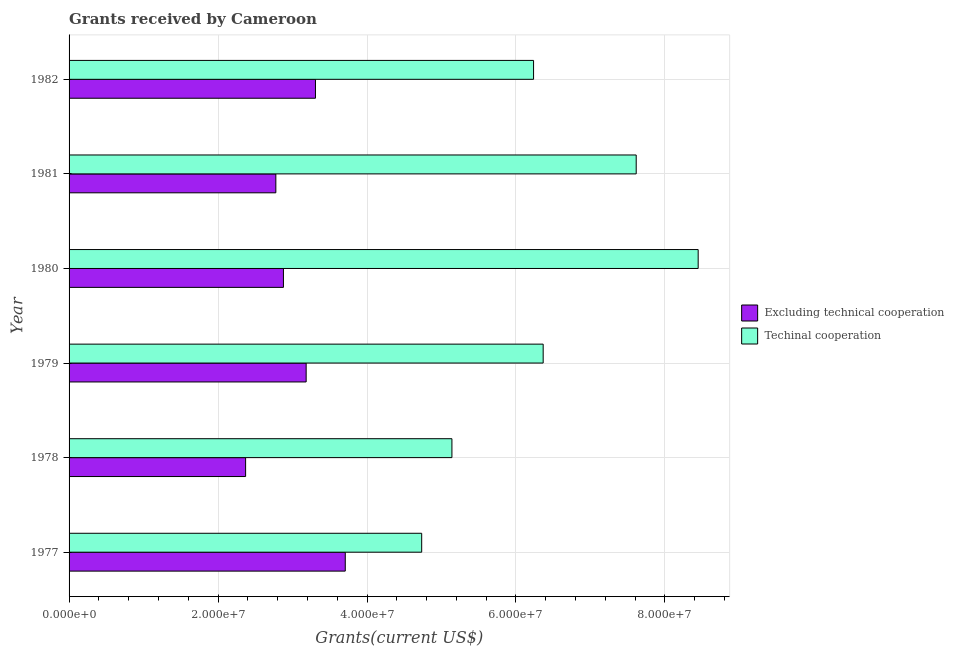How many different coloured bars are there?
Offer a terse response. 2. How many groups of bars are there?
Provide a short and direct response. 6. How many bars are there on the 2nd tick from the top?
Provide a short and direct response. 2. How many bars are there on the 3rd tick from the bottom?
Provide a succinct answer. 2. In how many cases, is the number of bars for a given year not equal to the number of legend labels?
Give a very brief answer. 0. What is the amount of grants received(including technical cooperation) in 1977?
Make the answer very short. 4.73e+07. Across all years, what is the maximum amount of grants received(excluding technical cooperation)?
Your response must be concise. 3.71e+07. Across all years, what is the minimum amount of grants received(including technical cooperation)?
Make the answer very short. 4.73e+07. In which year was the amount of grants received(including technical cooperation) maximum?
Keep it short and to the point. 1980. In which year was the amount of grants received(excluding technical cooperation) minimum?
Offer a very short reply. 1978. What is the total amount of grants received(excluding technical cooperation) in the graph?
Offer a very short reply. 1.82e+08. What is the difference between the amount of grants received(including technical cooperation) in 1978 and that in 1980?
Give a very brief answer. -3.31e+07. What is the difference between the amount of grants received(excluding technical cooperation) in 1981 and the amount of grants received(including technical cooperation) in 1982?
Offer a very short reply. -3.46e+07. What is the average amount of grants received(including technical cooperation) per year?
Give a very brief answer. 6.42e+07. In the year 1979, what is the difference between the amount of grants received(excluding technical cooperation) and amount of grants received(including technical cooperation)?
Give a very brief answer. -3.18e+07. In how many years, is the amount of grants received(including technical cooperation) greater than 44000000 US$?
Ensure brevity in your answer.  6. What is the ratio of the amount of grants received(excluding technical cooperation) in 1978 to that in 1980?
Provide a short and direct response. 0.82. Is the amount of grants received(excluding technical cooperation) in 1979 less than that in 1981?
Offer a terse response. No. Is the difference between the amount of grants received(excluding technical cooperation) in 1978 and 1982 greater than the difference between the amount of grants received(including technical cooperation) in 1978 and 1982?
Keep it short and to the point. Yes. What is the difference between the highest and the second highest amount of grants received(including technical cooperation)?
Your response must be concise. 8.32e+06. What is the difference between the highest and the lowest amount of grants received(excluding technical cooperation)?
Make the answer very short. 1.34e+07. What does the 1st bar from the top in 1977 represents?
Offer a very short reply. Techinal cooperation. What does the 1st bar from the bottom in 1982 represents?
Your response must be concise. Excluding technical cooperation. How many years are there in the graph?
Provide a short and direct response. 6. Are the values on the major ticks of X-axis written in scientific E-notation?
Your answer should be very brief. Yes. Does the graph contain any zero values?
Your answer should be compact. No. Does the graph contain grids?
Ensure brevity in your answer.  Yes. Where does the legend appear in the graph?
Provide a short and direct response. Center right. How are the legend labels stacked?
Give a very brief answer. Vertical. What is the title of the graph?
Make the answer very short. Grants received by Cameroon. What is the label or title of the X-axis?
Your answer should be compact. Grants(current US$). What is the Grants(current US$) in Excluding technical cooperation in 1977?
Your response must be concise. 3.71e+07. What is the Grants(current US$) of Techinal cooperation in 1977?
Your answer should be very brief. 4.73e+07. What is the Grants(current US$) of Excluding technical cooperation in 1978?
Your response must be concise. 2.37e+07. What is the Grants(current US$) in Techinal cooperation in 1978?
Give a very brief answer. 5.14e+07. What is the Grants(current US$) in Excluding technical cooperation in 1979?
Make the answer very short. 3.18e+07. What is the Grants(current US$) in Techinal cooperation in 1979?
Offer a very short reply. 6.36e+07. What is the Grants(current US$) in Excluding technical cooperation in 1980?
Your answer should be very brief. 2.88e+07. What is the Grants(current US$) of Techinal cooperation in 1980?
Make the answer very short. 8.45e+07. What is the Grants(current US$) of Excluding technical cooperation in 1981?
Your answer should be very brief. 2.78e+07. What is the Grants(current US$) in Techinal cooperation in 1981?
Give a very brief answer. 7.61e+07. What is the Grants(current US$) of Excluding technical cooperation in 1982?
Provide a succinct answer. 3.31e+07. What is the Grants(current US$) in Techinal cooperation in 1982?
Make the answer very short. 6.24e+07. Across all years, what is the maximum Grants(current US$) in Excluding technical cooperation?
Ensure brevity in your answer.  3.71e+07. Across all years, what is the maximum Grants(current US$) of Techinal cooperation?
Offer a very short reply. 8.45e+07. Across all years, what is the minimum Grants(current US$) of Excluding technical cooperation?
Provide a succinct answer. 2.37e+07. Across all years, what is the minimum Grants(current US$) in Techinal cooperation?
Your answer should be very brief. 4.73e+07. What is the total Grants(current US$) of Excluding technical cooperation in the graph?
Your answer should be very brief. 1.82e+08. What is the total Grants(current US$) of Techinal cooperation in the graph?
Your answer should be compact. 3.85e+08. What is the difference between the Grants(current US$) of Excluding technical cooperation in 1977 and that in 1978?
Offer a very short reply. 1.34e+07. What is the difference between the Grants(current US$) in Techinal cooperation in 1977 and that in 1978?
Your answer should be very brief. -4.06e+06. What is the difference between the Grants(current US$) in Excluding technical cooperation in 1977 and that in 1979?
Offer a terse response. 5.25e+06. What is the difference between the Grants(current US$) in Techinal cooperation in 1977 and that in 1979?
Keep it short and to the point. -1.63e+07. What is the difference between the Grants(current US$) in Excluding technical cooperation in 1977 and that in 1980?
Offer a terse response. 8.30e+06. What is the difference between the Grants(current US$) in Techinal cooperation in 1977 and that in 1980?
Your response must be concise. -3.71e+07. What is the difference between the Grants(current US$) of Excluding technical cooperation in 1977 and that in 1981?
Provide a short and direct response. 9.32e+06. What is the difference between the Grants(current US$) of Techinal cooperation in 1977 and that in 1981?
Your response must be concise. -2.88e+07. What is the difference between the Grants(current US$) in Techinal cooperation in 1977 and that in 1982?
Your answer should be compact. -1.50e+07. What is the difference between the Grants(current US$) of Excluding technical cooperation in 1978 and that in 1979?
Ensure brevity in your answer.  -8.13e+06. What is the difference between the Grants(current US$) of Techinal cooperation in 1978 and that in 1979?
Make the answer very short. -1.22e+07. What is the difference between the Grants(current US$) of Excluding technical cooperation in 1978 and that in 1980?
Ensure brevity in your answer.  -5.08e+06. What is the difference between the Grants(current US$) of Techinal cooperation in 1978 and that in 1980?
Keep it short and to the point. -3.31e+07. What is the difference between the Grants(current US$) in Excluding technical cooperation in 1978 and that in 1981?
Your response must be concise. -4.06e+06. What is the difference between the Grants(current US$) of Techinal cooperation in 1978 and that in 1981?
Provide a succinct answer. -2.47e+07. What is the difference between the Grants(current US$) of Excluding technical cooperation in 1978 and that in 1982?
Offer a terse response. -9.38e+06. What is the difference between the Grants(current US$) of Techinal cooperation in 1978 and that in 1982?
Your answer should be compact. -1.10e+07. What is the difference between the Grants(current US$) in Excluding technical cooperation in 1979 and that in 1980?
Your response must be concise. 3.05e+06. What is the difference between the Grants(current US$) in Techinal cooperation in 1979 and that in 1980?
Provide a short and direct response. -2.08e+07. What is the difference between the Grants(current US$) of Excluding technical cooperation in 1979 and that in 1981?
Offer a very short reply. 4.07e+06. What is the difference between the Grants(current US$) in Techinal cooperation in 1979 and that in 1981?
Your answer should be very brief. -1.25e+07. What is the difference between the Grants(current US$) in Excluding technical cooperation in 1979 and that in 1982?
Make the answer very short. -1.25e+06. What is the difference between the Grants(current US$) of Techinal cooperation in 1979 and that in 1982?
Make the answer very short. 1.29e+06. What is the difference between the Grants(current US$) of Excluding technical cooperation in 1980 and that in 1981?
Your answer should be very brief. 1.02e+06. What is the difference between the Grants(current US$) of Techinal cooperation in 1980 and that in 1981?
Provide a short and direct response. 8.32e+06. What is the difference between the Grants(current US$) of Excluding technical cooperation in 1980 and that in 1982?
Offer a very short reply. -4.30e+06. What is the difference between the Grants(current US$) of Techinal cooperation in 1980 and that in 1982?
Ensure brevity in your answer.  2.21e+07. What is the difference between the Grants(current US$) in Excluding technical cooperation in 1981 and that in 1982?
Keep it short and to the point. -5.32e+06. What is the difference between the Grants(current US$) in Techinal cooperation in 1981 and that in 1982?
Make the answer very short. 1.38e+07. What is the difference between the Grants(current US$) of Excluding technical cooperation in 1977 and the Grants(current US$) of Techinal cooperation in 1978?
Make the answer very short. -1.43e+07. What is the difference between the Grants(current US$) of Excluding technical cooperation in 1977 and the Grants(current US$) of Techinal cooperation in 1979?
Give a very brief answer. -2.66e+07. What is the difference between the Grants(current US$) of Excluding technical cooperation in 1977 and the Grants(current US$) of Techinal cooperation in 1980?
Make the answer very short. -4.74e+07. What is the difference between the Grants(current US$) of Excluding technical cooperation in 1977 and the Grants(current US$) of Techinal cooperation in 1981?
Ensure brevity in your answer.  -3.91e+07. What is the difference between the Grants(current US$) in Excluding technical cooperation in 1977 and the Grants(current US$) in Techinal cooperation in 1982?
Make the answer very short. -2.53e+07. What is the difference between the Grants(current US$) in Excluding technical cooperation in 1978 and the Grants(current US$) in Techinal cooperation in 1979?
Keep it short and to the point. -4.00e+07. What is the difference between the Grants(current US$) of Excluding technical cooperation in 1978 and the Grants(current US$) of Techinal cooperation in 1980?
Offer a terse response. -6.08e+07. What is the difference between the Grants(current US$) in Excluding technical cooperation in 1978 and the Grants(current US$) in Techinal cooperation in 1981?
Offer a very short reply. -5.24e+07. What is the difference between the Grants(current US$) in Excluding technical cooperation in 1978 and the Grants(current US$) in Techinal cooperation in 1982?
Give a very brief answer. -3.87e+07. What is the difference between the Grants(current US$) in Excluding technical cooperation in 1979 and the Grants(current US$) in Techinal cooperation in 1980?
Offer a very short reply. -5.26e+07. What is the difference between the Grants(current US$) in Excluding technical cooperation in 1979 and the Grants(current US$) in Techinal cooperation in 1981?
Your response must be concise. -4.43e+07. What is the difference between the Grants(current US$) in Excluding technical cooperation in 1979 and the Grants(current US$) in Techinal cooperation in 1982?
Provide a succinct answer. -3.05e+07. What is the difference between the Grants(current US$) of Excluding technical cooperation in 1980 and the Grants(current US$) of Techinal cooperation in 1981?
Provide a succinct answer. -4.74e+07. What is the difference between the Grants(current US$) of Excluding technical cooperation in 1980 and the Grants(current US$) of Techinal cooperation in 1982?
Your answer should be very brief. -3.36e+07. What is the difference between the Grants(current US$) in Excluding technical cooperation in 1981 and the Grants(current US$) in Techinal cooperation in 1982?
Make the answer very short. -3.46e+07. What is the average Grants(current US$) of Excluding technical cooperation per year?
Provide a succinct answer. 3.04e+07. What is the average Grants(current US$) in Techinal cooperation per year?
Ensure brevity in your answer.  6.42e+07. In the year 1977, what is the difference between the Grants(current US$) of Excluding technical cooperation and Grants(current US$) of Techinal cooperation?
Offer a very short reply. -1.03e+07. In the year 1978, what is the difference between the Grants(current US$) of Excluding technical cooperation and Grants(current US$) of Techinal cooperation?
Keep it short and to the point. -2.77e+07. In the year 1979, what is the difference between the Grants(current US$) of Excluding technical cooperation and Grants(current US$) of Techinal cooperation?
Offer a terse response. -3.18e+07. In the year 1980, what is the difference between the Grants(current US$) of Excluding technical cooperation and Grants(current US$) of Techinal cooperation?
Provide a short and direct response. -5.57e+07. In the year 1981, what is the difference between the Grants(current US$) of Excluding technical cooperation and Grants(current US$) of Techinal cooperation?
Your answer should be very brief. -4.84e+07. In the year 1982, what is the difference between the Grants(current US$) in Excluding technical cooperation and Grants(current US$) in Techinal cooperation?
Offer a very short reply. -2.93e+07. What is the ratio of the Grants(current US$) in Excluding technical cooperation in 1977 to that in 1978?
Provide a succinct answer. 1.56. What is the ratio of the Grants(current US$) in Techinal cooperation in 1977 to that in 1978?
Offer a very short reply. 0.92. What is the ratio of the Grants(current US$) in Excluding technical cooperation in 1977 to that in 1979?
Offer a very short reply. 1.16. What is the ratio of the Grants(current US$) of Techinal cooperation in 1977 to that in 1979?
Your response must be concise. 0.74. What is the ratio of the Grants(current US$) of Excluding technical cooperation in 1977 to that in 1980?
Your answer should be very brief. 1.29. What is the ratio of the Grants(current US$) of Techinal cooperation in 1977 to that in 1980?
Your answer should be very brief. 0.56. What is the ratio of the Grants(current US$) of Excluding technical cooperation in 1977 to that in 1981?
Provide a succinct answer. 1.34. What is the ratio of the Grants(current US$) of Techinal cooperation in 1977 to that in 1981?
Your answer should be compact. 0.62. What is the ratio of the Grants(current US$) in Excluding technical cooperation in 1977 to that in 1982?
Your answer should be very brief. 1.12. What is the ratio of the Grants(current US$) in Techinal cooperation in 1977 to that in 1982?
Your response must be concise. 0.76. What is the ratio of the Grants(current US$) of Excluding technical cooperation in 1978 to that in 1979?
Offer a terse response. 0.74. What is the ratio of the Grants(current US$) in Techinal cooperation in 1978 to that in 1979?
Keep it short and to the point. 0.81. What is the ratio of the Grants(current US$) in Excluding technical cooperation in 1978 to that in 1980?
Offer a terse response. 0.82. What is the ratio of the Grants(current US$) in Techinal cooperation in 1978 to that in 1980?
Your answer should be compact. 0.61. What is the ratio of the Grants(current US$) in Excluding technical cooperation in 1978 to that in 1981?
Offer a very short reply. 0.85. What is the ratio of the Grants(current US$) of Techinal cooperation in 1978 to that in 1981?
Offer a terse response. 0.68. What is the ratio of the Grants(current US$) in Excluding technical cooperation in 1978 to that in 1982?
Provide a succinct answer. 0.72. What is the ratio of the Grants(current US$) of Techinal cooperation in 1978 to that in 1982?
Offer a terse response. 0.82. What is the ratio of the Grants(current US$) in Excluding technical cooperation in 1979 to that in 1980?
Offer a very short reply. 1.11. What is the ratio of the Grants(current US$) of Techinal cooperation in 1979 to that in 1980?
Ensure brevity in your answer.  0.75. What is the ratio of the Grants(current US$) of Excluding technical cooperation in 1979 to that in 1981?
Provide a succinct answer. 1.15. What is the ratio of the Grants(current US$) in Techinal cooperation in 1979 to that in 1981?
Give a very brief answer. 0.84. What is the ratio of the Grants(current US$) of Excluding technical cooperation in 1979 to that in 1982?
Ensure brevity in your answer.  0.96. What is the ratio of the Grants(current US$) in Techinal cooperation in 1979 to that in 1982?
Offer a very short reply. 1.02. What is the ratio of the Grants(current US$) in Excluding technical cooperation in 1980 to that in 1981?
Provide a short and direct response. 1.04. What is the ratio of the Grants(current US$) of Techinal cooperation in 1980 to that in 1981?
Keep it short and to the point. 1.11. What is the ratio of the Grants(current US$) of Excluding technical cooperation in 1980 to that in 1982?
Your response must be concise. 0.87. What is the ratio of the Grants(current US$) of Techinal cooperation in 1980 to that in 1982?
Keep it short and to the point. 1.35. What is the ratio of the Grants(current US$) in Excluding technical cooperation in 1981 to that in 1982?
Ensure brevity in your answer.  0.84. What is the ratio of the Grants(current US$) in Techinal cooperation in 1981 to that in 1982?
Make the answer very short. 1.22. What is the difference between the highest and the second highest Grants(current US$) in Techinal cooperation?
Keep it short and to the point. 8.32e+06. What is the difference between the highest and the lowest Grants(current US$) of Excluding technical cooperation?
Provide a succinct answer. 1.34e+07. What is the difference between the highest and the lowest Grants(current US$) in Techinal cooperation?
Provide a succinct answer. 3.71e+07. 